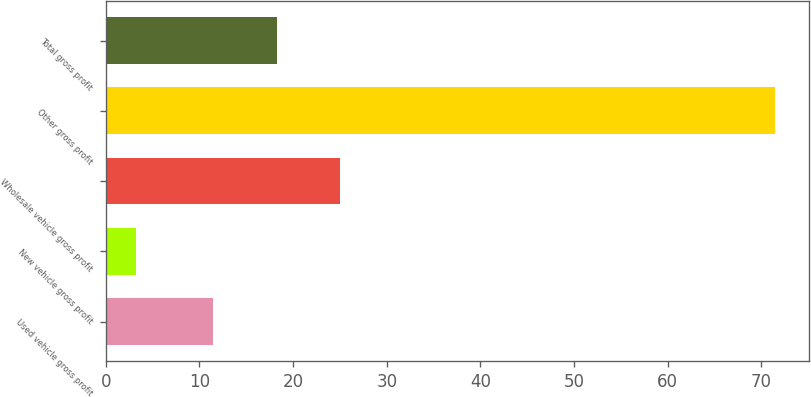Convert chart to OTSL. <chart><loc_0><loc_0><loc_500><loc_500><bar_chart><fcel>Used vehicle gross profit<fcel>New vehicle gross profit<fcel>Wholesale vehicle gross profit<fcel>Other gross profit<fcel>Total gross profit<nl><fcel>11.4<fcel>3.2<fcel>25.06<fcel>71.5<fcel>18.23<nl></chart> 